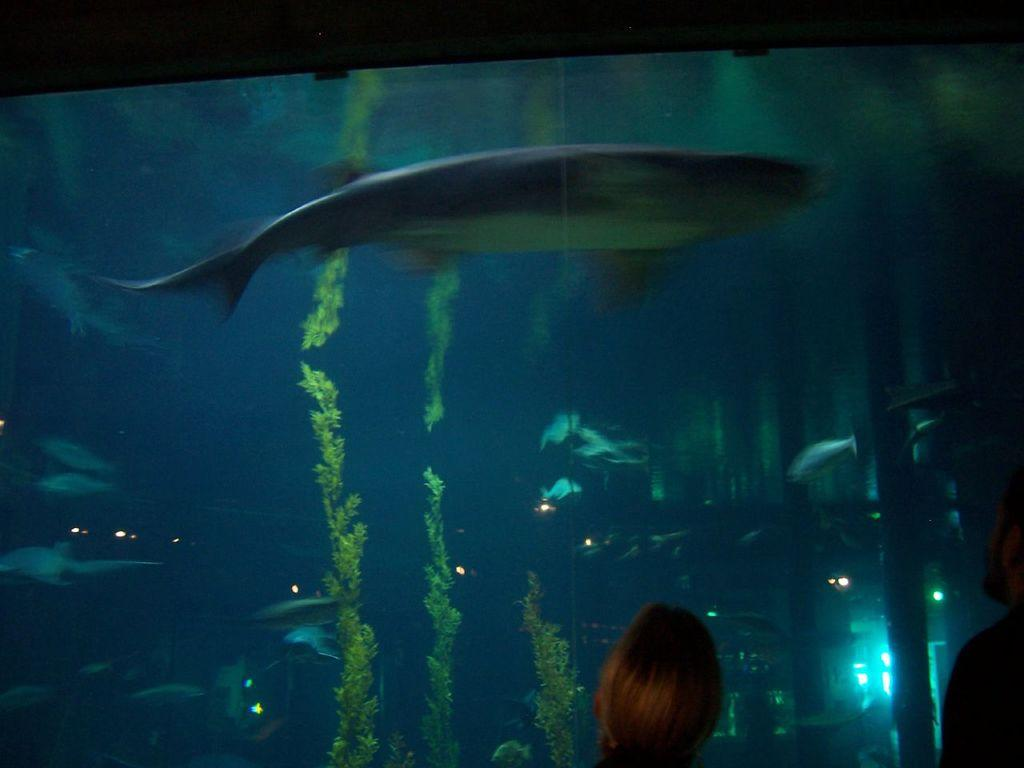Who are the two people in the foreground of the image? The facts do not provide information about the identities of the two people. What can be seen in the background of the image? There is an aquarium in the background of the image. What types of creatures are inside the aquarium? There are fishes inside the aquarium. What else is present inside the aquarium besides the fishes? There are plants inside the aquarium. What type of furniture can be seen in the image? There is no furniture present in the image; it features two people in the foreground and an aquarium in the background. 